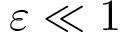<formula> <loc_0><loc_0><loc_500><loc_500>\varepsilon \ll 1</formula> 